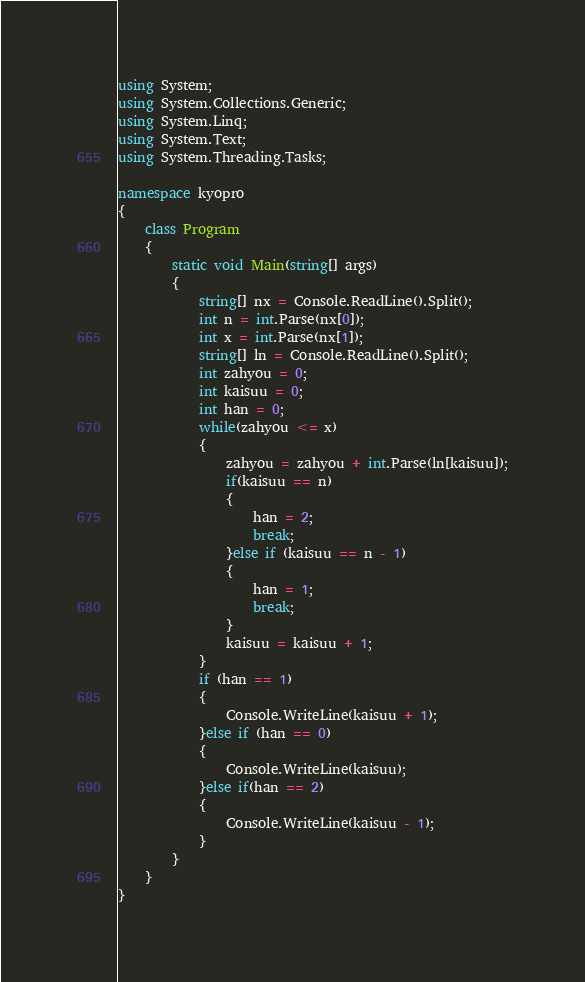Convert code to text. <code><loc_0><loc_0><loc_500><loc_500><_C#_>using System;
using System.Collections.Generic;
using System.Linq;
using System.Text;
using System.Threading.Tasks;

namespace kyopro
{
    class Program
    {
        static void Main(string[] args)
        {
            string[] nx = Console.ReadLine().Split();
            int n = int.Parse(nx[0]);
            int x = int.Parse(nx[1]);
            string[] ln = Console.ReadLine().Split();
            int zahyou = 0;
            int kaisuu = 0;
            int han = 0;
            while(zahyou <= x)
            {
                zahyou = zahyou + int.Parse(ln[kaisuu]);
                if(kaisuu == n)
                {
                    han = 2;
                    break;
                }else if (kaisuu == n - 1)
                {
                    han = 1;
                    break;
                }
                kaisuu = kaisuu + 1;
            }
            if (han == 1)
            {
                Console.WriteLine(kaisuu + 1);
            }else if (han == 0)
            {
                Console.WriteLine(kaisuu);
            }else if(han == 2)
            {
                Console.WriteLine(kaisuu - 1);
            }
        }
    }
}
</code> 